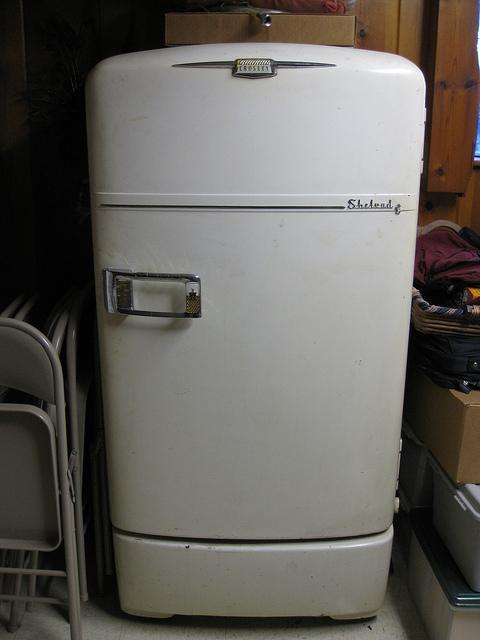How many handles do you see?
Give a very brief answer. 1. How many chairs are there?
Give a very brief answer. 2. How many people are at this table?
Give a very brief answer. 0. 